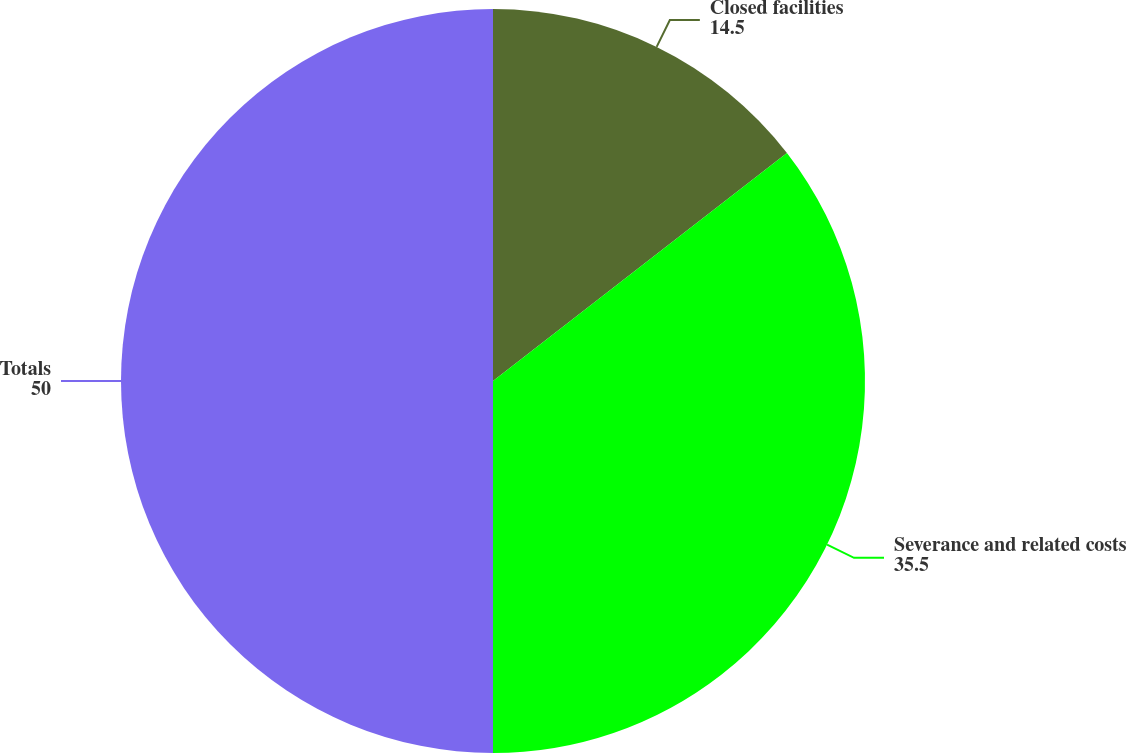Convert chart. <chart><loc_0><loc_0><loc_500><loc_500><pie_chart><fcel>Closed facilities<fcel>Severance and related costs<fcel>Totals<nl><fcel>14.5%<fcel>35.5%<fcel>50.0%<nl></chart> 